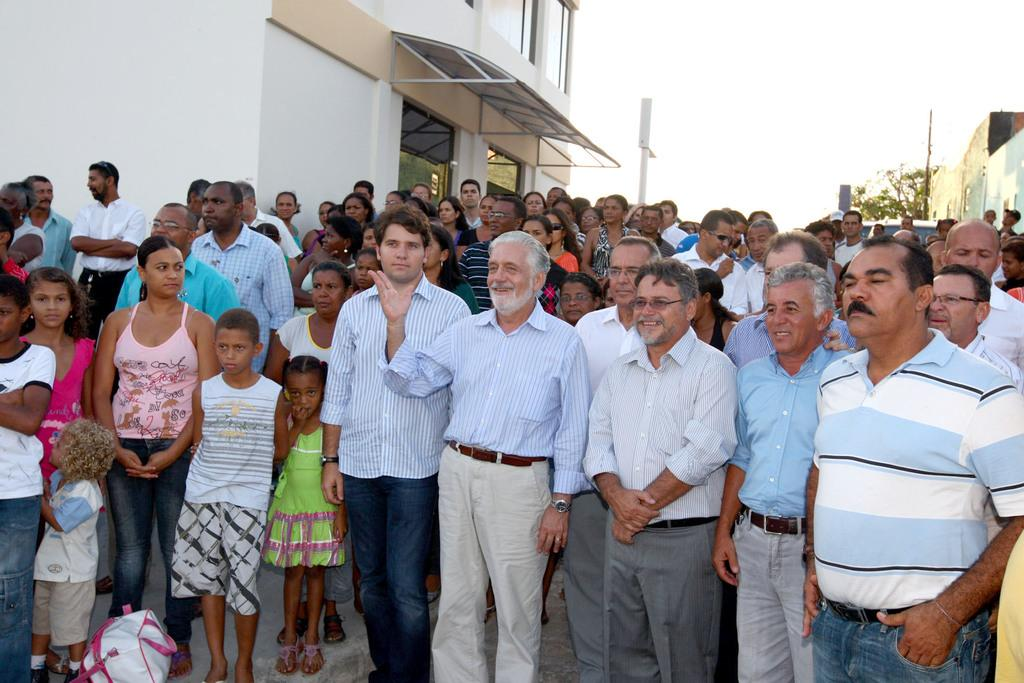What is the main subject of the image? The main subject of the image is a group of people standing in the middle of the image. What can be seen on the left side of the image? There is a building on the left side of the image. What type of vegetation is on the right side of the image? There is a tree on the right side of the image. What is visible at the top of the image? The sky is visible at the top of the image. How many clovers are visible on the tree in the image? There are no clovers visible on the tree in the image, as the tree is not a type of plant that produces clovers. 